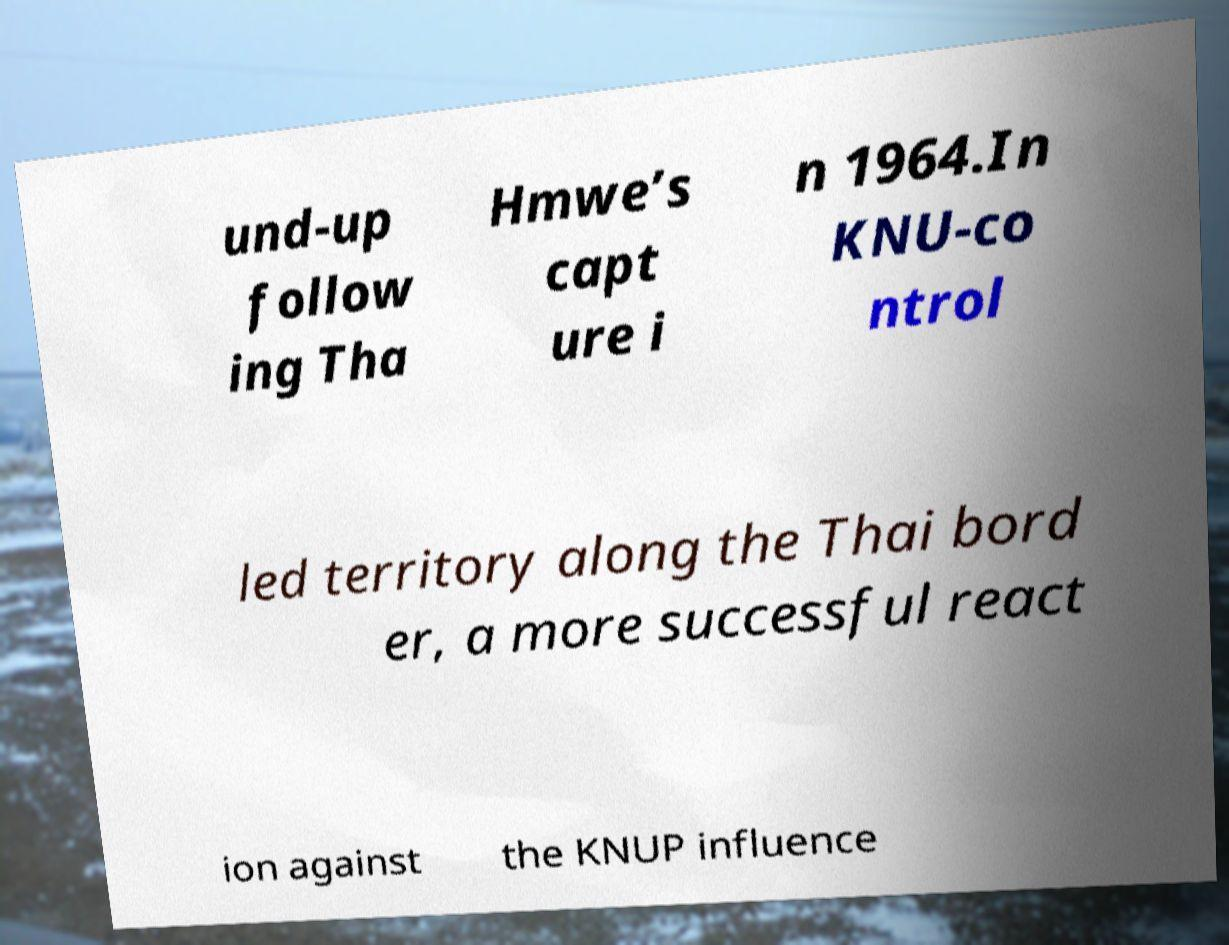Please read and relay the text visible in this image. What does it say? und-up follow ing Tha Hmwe’s capt ure i n 1964.In KNU-co ntrol led territory along the Thai bord er, a more successful react ion against the KNUP influence 